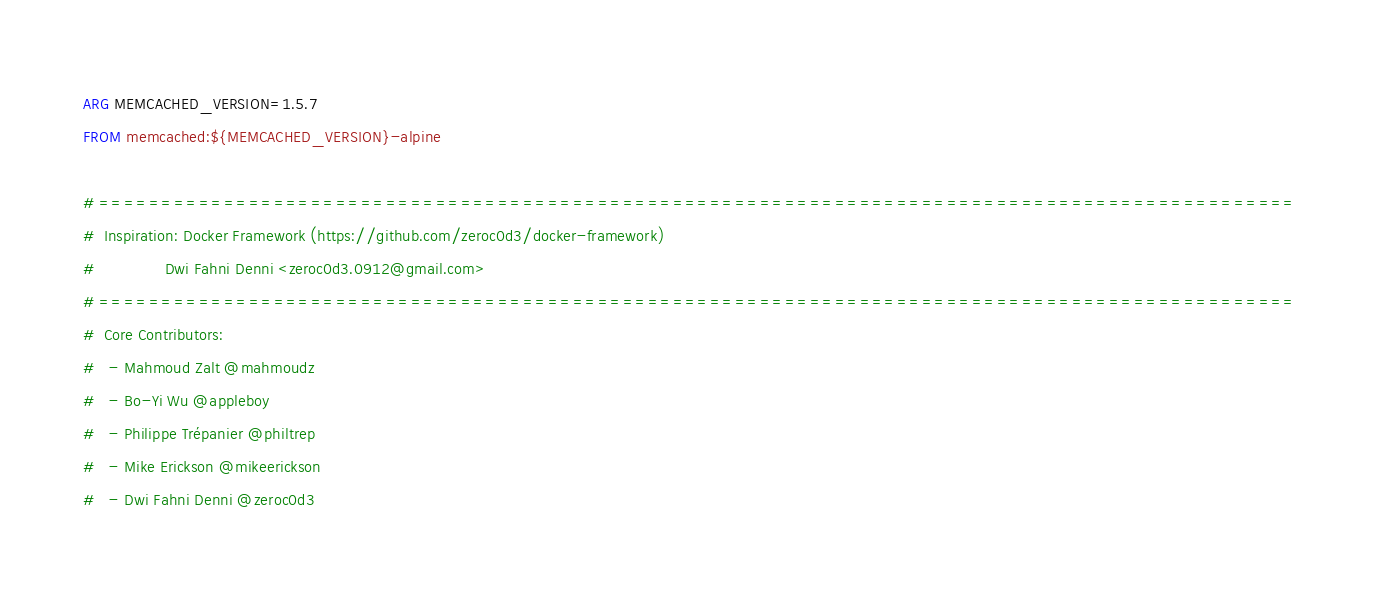Convert code to text. <code><loc_0><loc_0><loc_500><loc_500><_Dockerfile_>ARG MEMCACHED_VERSION=1.5.7
FROM memcached:${MEMCACHED_VERSION}-alpine

# ================================================================================================
#  Inspiration: Docker Framework (https://github.com/zeroc0d3/docker-framework)
#               Dwi Fahni Denni <zeroc0d3.0912@gmail.com>
# ================================================================================================
#  Core Contributors:
#   - Mahmoud Zalt @mahmoudz
#   - Bo-Yi Wu @appleboy
#   - Philippe Trépanier @philtrep
#   - Mike Erickson @mikeerickson
#   - Dwi Fahni Denni @zeroc0d3</code> 